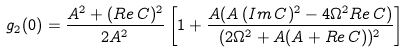<formula> <loc_0><loc_0><loc_500><loc_500>g _ { 2 } ( 0 ) = \frac { A ^ { 2 } + ( R e \, C ) ^ { 2 } } { 2 A ^ { 2 } } \left [ 1 + \frac { A ( A \, ( I m \, C ) ^ { 2 } - 4 \Omega ^ { 2 } R e \, C ) } { ( 2 \Omega ^ { 2 } + A ( A + R e \, C ) ) ^ { 2 } } \right ]</formula> 